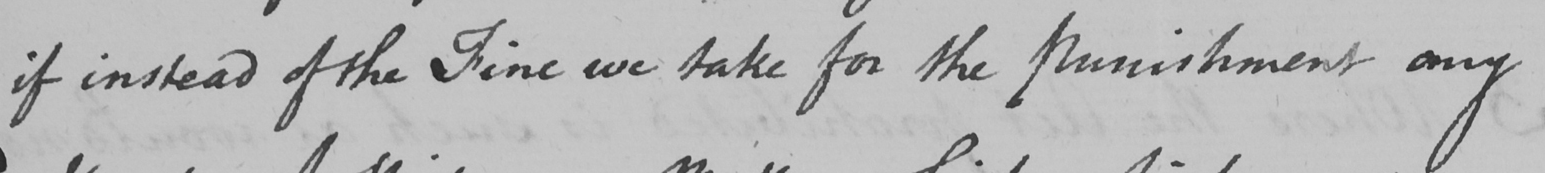Can you read and transcribe this handwriting? if instead of the Fine we take for the Punishment any 